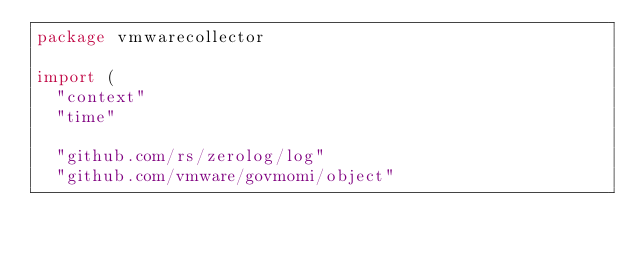Convert code to text. <code><loc_0><loc_0><loc_500><loc_500><_Go_>package vmwarecollector

import (
	"context"
	"time"

	"github.com/rs/zerolog/log"
	"github.com/vmware/govmomi/object"</code> 